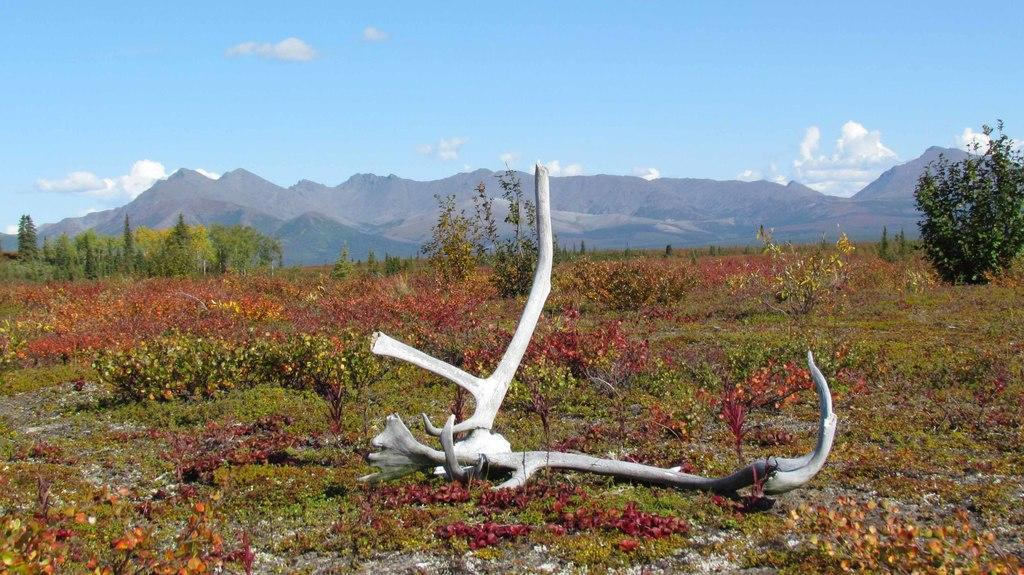What can be found on the land in the image? There are bones on the land in the image. What type of vegetation is present in the image? There are plants and trees in the image. What can be seen in the background of the image? There are hills visible in the background of the image. What is visible at the top of the image? The sky is visible at the top of the image. How much profit did the dolls generate in the image? There are no dolls present in the image, so it is not possible to determine any profit generated. 